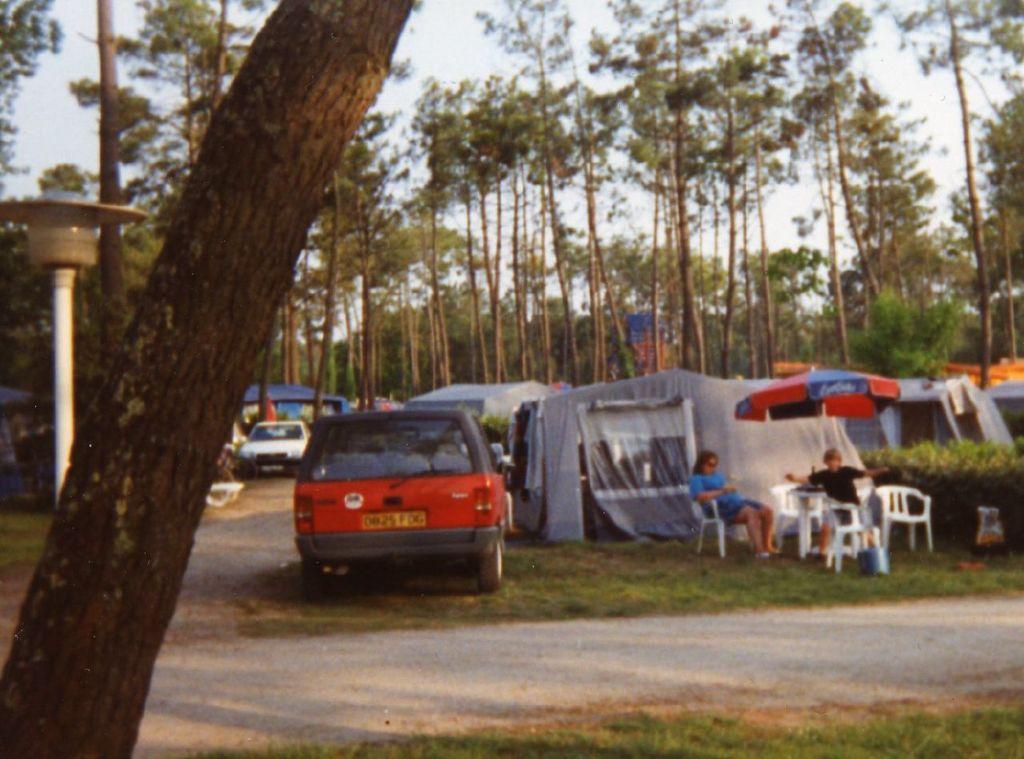Please provide a concise description of this image. In the foreground of this image, there is a tree trunk and a path to which two sides there is grass. In the background, there are tents, an umbrella under which, there are persons sitting on the chairs, a vehicle on the grass, a white car, a pole on the left, trees and the sky. 